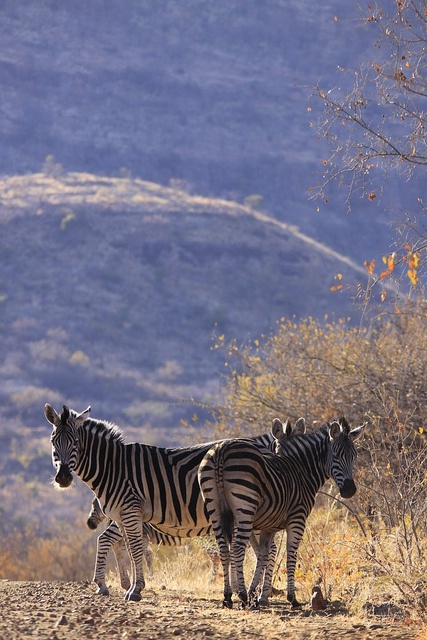Describe the objects in this image and their specific colors. I can see zebra in gray and black tones, zebra in gray and black tones, zebra in gray, tan, and black tones, and bird in gray, maroon, and black tones in this image. 